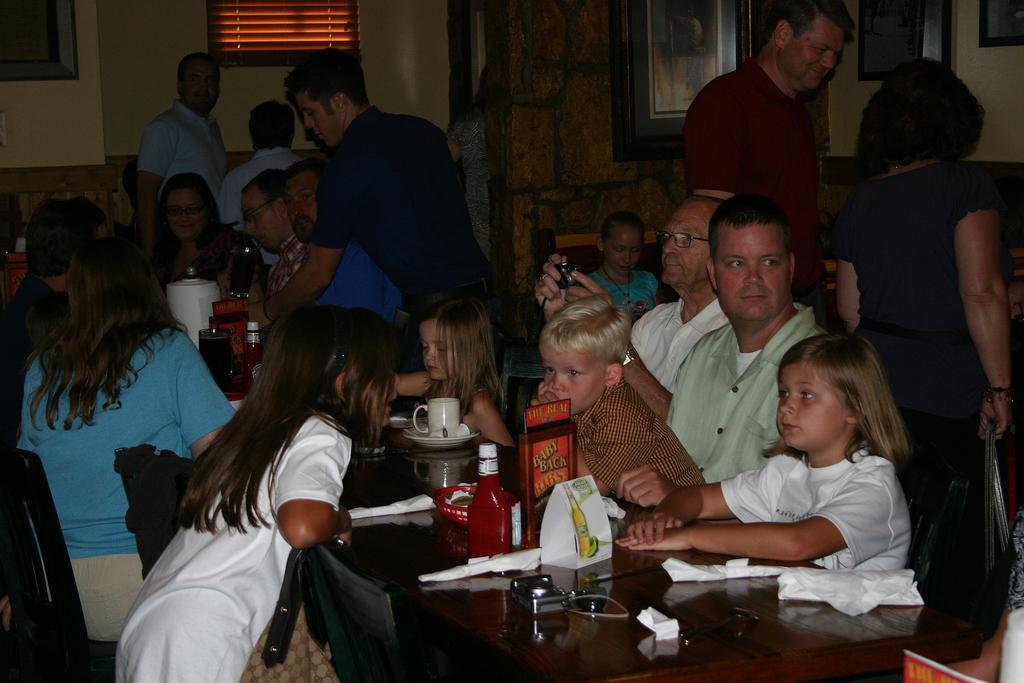Describe this image in one or two sentences. In this image there are few people sitting on chairs. In the middle there is a dining table. On dining table there are cup ,plates, pouch, bottles, napkins. Here a person is clicking photo. There are few persons standing. In the wall there are paintings. 